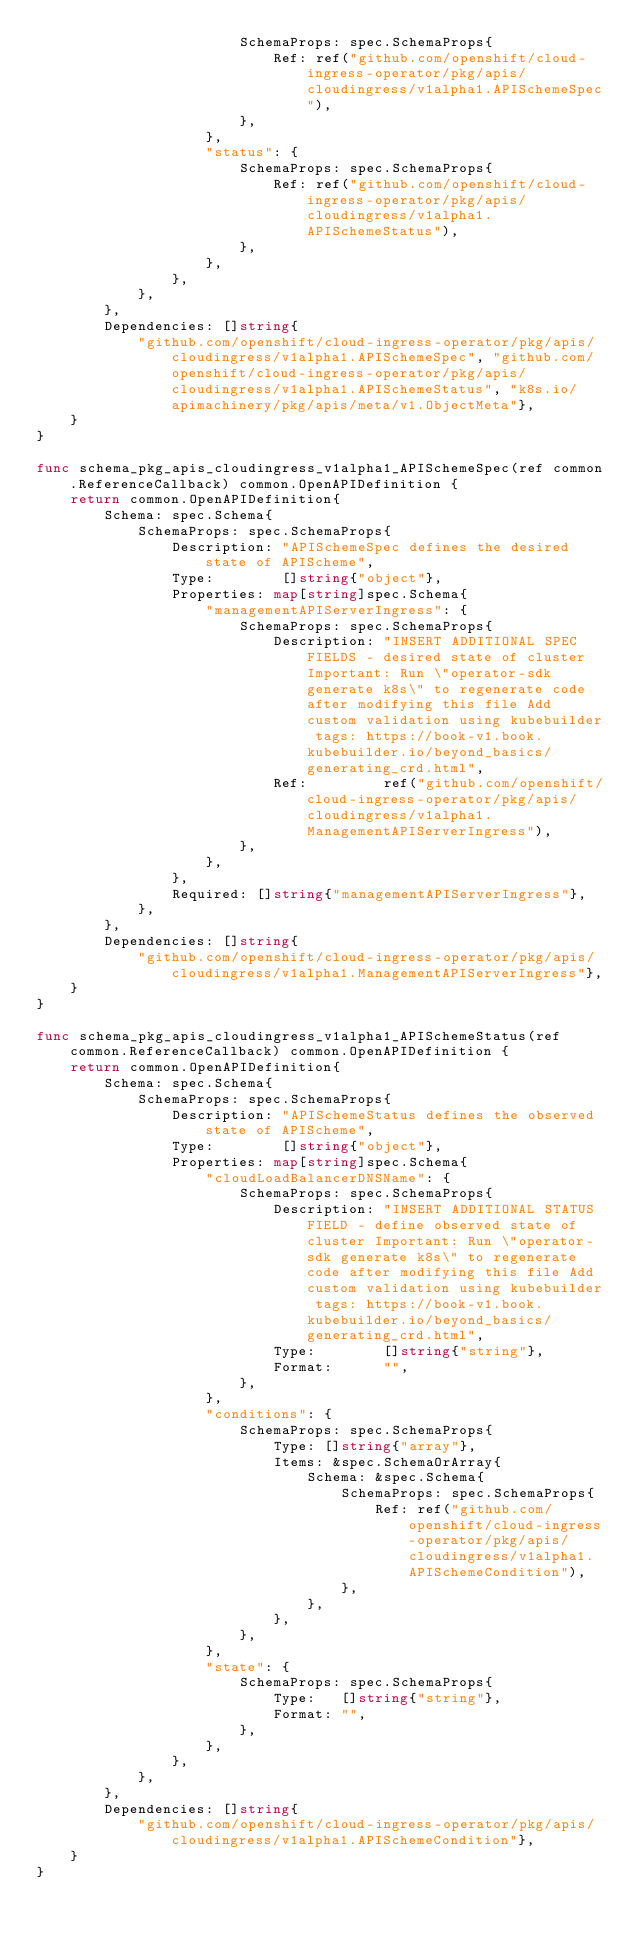<code> <loc_0><loc_0><loc_500><loc_500><_Go_>						SchemaProps: spec.SchemaProps{
							Ref: ref("github.com/openshift/cloud-ingress-operator/pkg/apis/cloudingress/v1alpha1.APISchemeSpec"),
						},
					},
					"status": {
						SchemaProps: spec.SchemaProps{
							Ref: ref("github.com/openshift/cloud-ingress-operator/pkg/apis/cloudingress/v1alpha1.APISchemeStatus"),
						},
					},
				},
			},
		},
		Dependencies: []string{
			"github.com/openshift/cloud-ingress-operator/pkg/apis/cloudingress/v1alpha1.APISchemeSpec", "github.com/openshift/cloud-ingress-operator/pkg/apis/cloudingress/v1alpha1.APISchemeStatus", "k8s.io/apimachinery/pkg/apis/meta/v1.ObjectMeta"},
	}
}

func schema_pkg_apis_cloudingress_v1alpha1_APISchemeSpec(ref common.ReferenceCallback) common.OpenAPIDefinition {
	return common.OpenAPIDefinition{
		Schema: spec.Schema{
			SchemaProps: spec.SchemaProps{
				Description: "APISchemeSpec defines the desired state of APIScheme",
				Type:        []string{"object"},
				Properties: map[string]spec.Schema{
					"managementAPIServerIngress": {
						SchemaProps: spec.SchemaProps{
							Description: "INSERT ADDITIONAL SPEC FIELDS - desired state of cluster Important: Run \"operator-sdk generate k8s\" to regenerate code after modifying this file Add custom validation using kubebuilder tags: https://book-v1.book.kubebuilder.io/beyond_basics/generating_crd.html",
							Ref:         ref("github.com/openshift/cloud-ingress-operator/pkg/apis/cloudingress/v1alpha1.ManagementAPIServerIngress"),
						},
					},
				},
				Required: []string{"managementAPIServerIngress"},
			},
		},
		Dependencies: []string{
			"github.com/openshift/cloud-ingress-operator/pkg/apis/cloudingress/v1alpha1.ManagementAPIServerIngress"},
	}
}

func schema_pkg_apis_cloudingress_v1alpha1_APISchemeStatus(ref common.ReferenceCallback) common.OpenAPIDefinition {
	return common.OpenAPIDefinition{
		Schema: spec.Schema{
			SchemaProps: spec.SchemaProps{
				Description: "APISchemeStatus defines the observed state of APIScheme",
				Type:        []string{"object"},
				Properties: map[string]spec.Schema{
					"cloudLoadBalancerDNSName": {
						SchemaProps: spec.SchemaProps{
							Description: "INSERT ADDITIONAL STATUS FIELD - define observed state of cluster Important: Run \"operator-sdk generate k8s\" to regenerate code after modifying this file Add custom validation using kubebuilder tags: https://book-v1.book.kubebuilder.io/beyond_basics/generating_crd.html",
							Type:        []string{"string"},
							Format:      "",
						},
					},
					"conditions": {
						SchemaProps: spec.SchemaProps{
							Type: []string{"array"},
							Items: &spec.SchemaOrArray{
								Schema: &spec.Schema{
									SchemaProps: spec.SchemaProps{
										Ref: ref("github.com/openshift/cloud-ingress-operator/pkg/apis/cloudingress/v1alpha1.APISchemeCondition"),
									},
								},
							},
						},
					},
					"state": {
						SchemaProps: spec.SchemaProps{
							Type:   []string{"string"},
							Format: "",
						},
					},
				},
			},
		},
		Dependencies: []string{
			"github.com/openshift/cloud-ingress-operator/pkg/apis/cloudingress/v1alpha1.APISchemeCondition"},
	}
}
</code> 